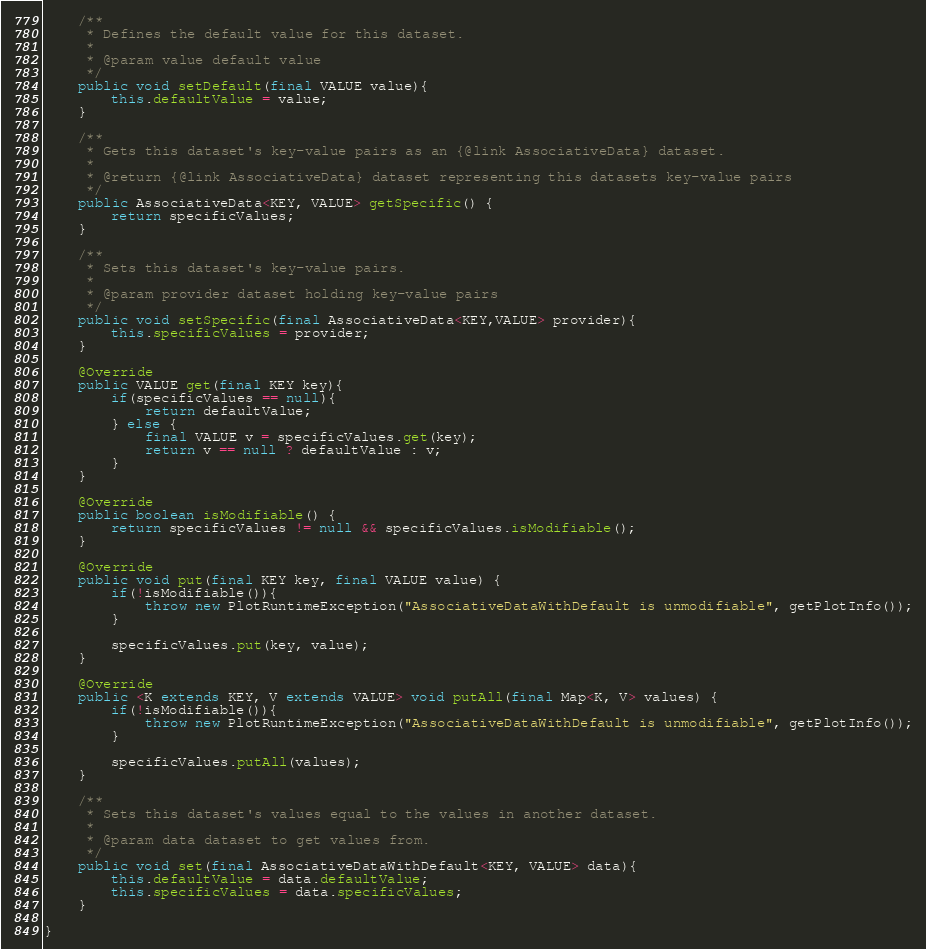<code> <loc_0><loc_0><loc_500><loc_500><_Java_>
    /**
     * Defines the default value for this dataset.
     *
     * @param value default value
     */
    public void setDefault(final VALUE value){
        this.defaultValue = value;
    }

    /**
     * Gets this dataset's key-value pairs as an {@link AssociativeData} dataset.
     *
     * @return {@link AssociativeData} dataset representing this datasets key-value pairs
     */
    public AssociativeData<KEY, VALUE> getSpecific() {
        return specificValues;
    }

    /**
     * Sets this dataset's key-value pairs.
     *
     * @param provider dataset holding key-value pairs
     */
    public void setSpecific(final AssociativeData<KEY,VALUE> provider){
        this.specificValues = provider;
    }

    @Override
    public VALUE get(final KEY key){
        if(specificValues == null){
            return defaultValue;
        } else {
            final VALUE v = specificValues.get(key);
            return v == null ? defaultValue : v;
        }
    }

    @Override
    public boolean isModifiable() {
        return specificValues != null && specificValues.isModifiable();
    }

    @Override
    public void put(final KEY key, final VALUE value) {
        if(!isModifiable()){
            throw new PlotRuntimeException("AssociativeDataWithDefault is unmodifiable", getPlotInfo());
        }

        specificValues.put(key, value);
    }

    @Override
    public <K extends KEY, V extends VALUE> void putAll(final Map<K, V> values) {
        if(!isModifiable()){
            throw new PlotRuntimeException("AssociativeDataWithDefault is unmodifiable", getPlotInfo());
        }

        specificValues.putAll(values);
    }

    /**
     * Sets this dataset's values equal to the values in another dataset.
     *
     * @param data dataset to get values from.
     */
    public void set(final AssociativeDataWithDefault<KEY, VALUE> data){
        this.defaultValue = data.defaultValue;
        this.specificValues = data.specificValues;
    }

}
</code> 